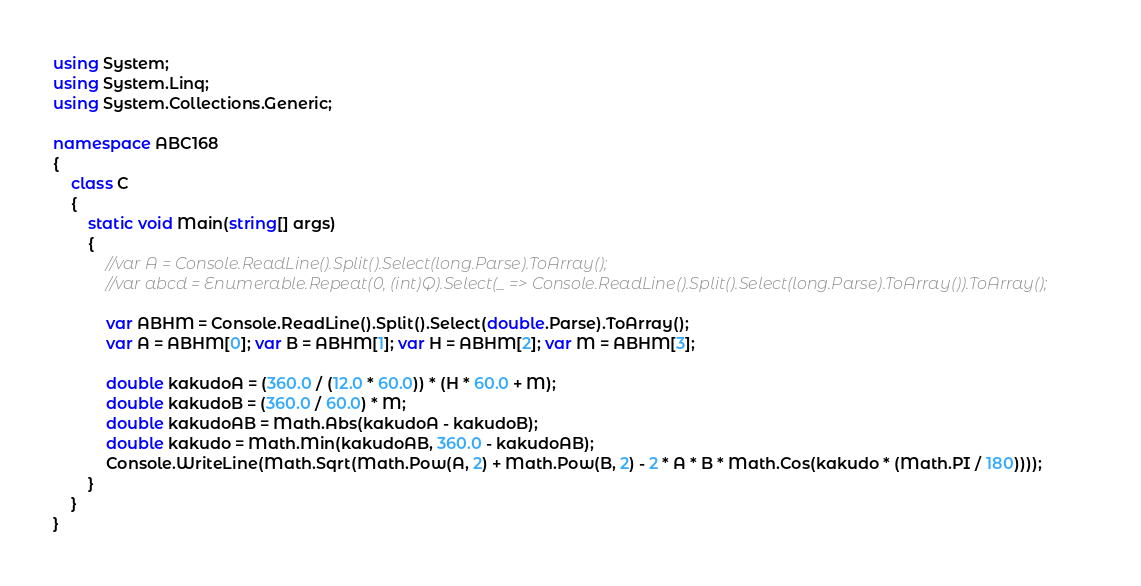<code> <loc_0><loc_0><loc_500><loc_500><_C#_>using System;
using System.Linq;
using System.Collections.Generic;

namespace ABC168
{
    class C
    {
        static void Main(string[] args)
        {
            //var A = Console.ReadLine().Split().Select(long.Parse).ToArray();
            //var abcd = Enumerable.Repeat(0, (int)Q).Select(_ => Console.ReadLine().Split().Select(long.Parse).ToArray()).ToArray();

            var ABHM = Console.ReadLine().Split().Select(double.Parse).ToArray();
            var A = ABHM[0]; var B = ABHM[1]; var H = ABHM[2]; var M = ABHM[3];

            double kakudoA = (360.0 / (12.0 * 60.0)) * (H * 60.0 + M);
            double kakudoB = (360.0 / 60.0) * M;
            double kakudoAB = Math.Abs(kakudoA - kakudoB);
            double kakudo = Math.Min(kakudoAB, 360.0 - kakudoAB);
            Console.WriteLine(Math.Sqrt(Math.Pow(A, 2) + Math.Pow(B, 2) - 2 * A * B * Math.Cos(kakudo * (Math.PI / 180))));
        }
    }
}
</code> 